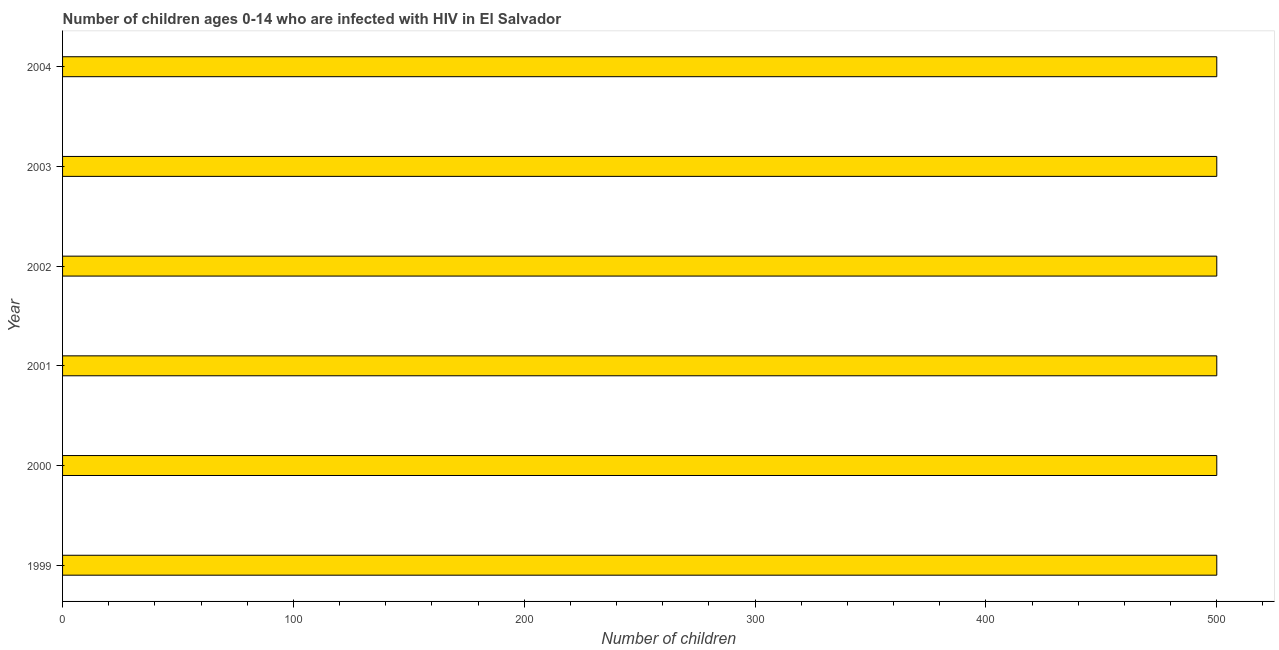Does the graph contain any zero values?
Offer a terse response. No. What is the title of the graph?
Your answer should be very brief. Number of children ages 0-14 who are infected with HIV in El Salvador. What is the label or title of the X-axis?
Your answer should be compact. Number of children. What is the label or title of the Y-axis?
Provide a succinct answer. Year. Across all years, what is the maximum number of children living with hiv?
Offer a very short reply. 500. Across all years, what is the minimum number of children living with hiv?
Your answer should be compact. 500. In which year was the number of children living with hiv maximum?
Your response must be concise. 1999. What is the sum of the number of children living with hiv?
Your answer should be compact. 3000. In how many years, is the number of children living with hiv greater than 100 ?
Provide a succinct answer. 6. Is the number of children living with hiv in 2001 less than that in 2002?
Your response must be concise. No. In how many years, is the number of children living with hiv greater than the average number of children living with hiv taken over all years?
Keep it short and to the point. 0. How many bars are there?
Your answer should be very brief. 6. Are all the bars in the graph horizontal?
Provide a short and direct response. Yes. How many years are there in the graph?
Make the answer very short. 6. What is the difference between two consecutive major ticks on the X-axis?
Offer a terse response. 100. Are the values on the major ticks of X-axis written in scientific E-notation?
Make the answer very short. No. What is the difference between the Number of children in 1999 and 2000?
Ensure brevity in your answer.  0. What is the difference between the Number of children in 1999 and 2004?
Make the answer very short. 0. What is the difference between the Number of children in 2000 and 2001?
Give a very brief answer. 0. What is the difference between the Number of children in 2001 and 2003?
Give a very brief answer. 0. What is the difference between the Number of children in 2002 and 2004?
Give a very brief answer. 0. What is the difference between the Number of children in 2003 and 2004?
Offer a terse response. 0. What is the ratio of the Number of children in 1999 to that in 2003?
Your response must be concise. 1. What is the ratio of the Number of children in 1999 to that in 2004?
Provide a succinct answer. 1. What is the ratio of the Number of children in 2000 to that in 2001?
Offer a very short reply. 1. What is the ratio of the Number of children in 2000 to that in 2002?
Your answer should be compact. 1. What is the ratio of the Number of children in 2000 to that in 2003?
Give a very brief answer. 1. What is the ratio of the Number of children in 2000 to that in 2004?
Your answer should be very brief. 1. What is the ratio of the Number of children in 2001 to that in 2003?
Provide a succinct answer. 1. What is the ratio of the Number of children in 2001 to that in 2004?
Your response must be concise. 1. What is the ratio of the Number of children in 2002 to that in 2003?
Offer a terse response. 1. What is the ratio of the Number of children in 2003 to that in 2004?
Your answer should be compact. 1. 